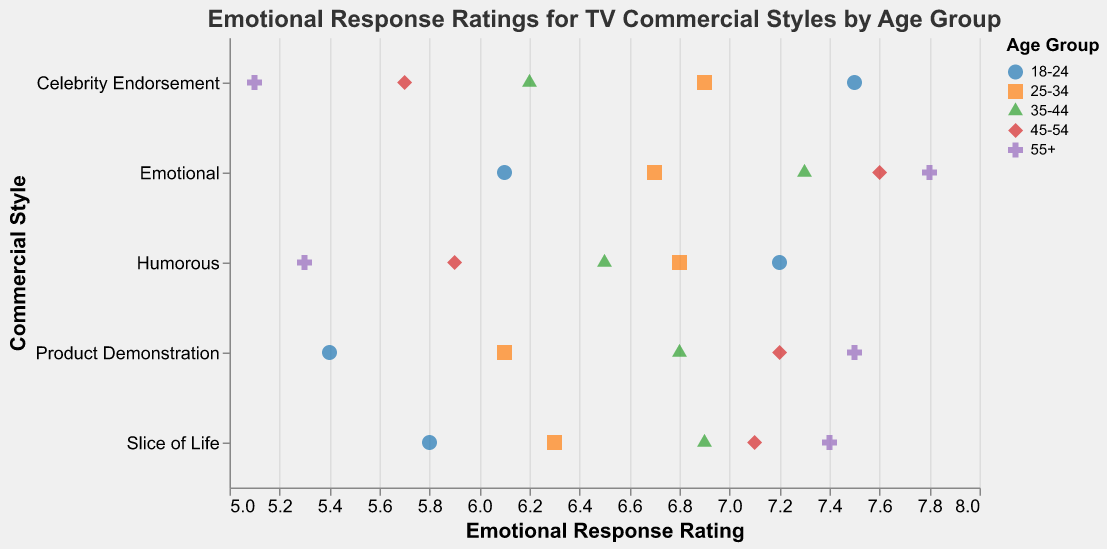What is the range of the "Emotional Response Rating" axis? The "Emotional Response Rating" axis ranges from 5 to 8, as shown by the scale domain on the x-axis.
Answer: 5 to 8 Which commercial style has the highest emotional response rating for the 55+ age group? The "Emotional" commercial style has the highest emotional response rating for the 55+ age group, with a score of 7.8.
Answer: Emotional How does the emotional response rating for "Humorous" commercials change as the age group increases? The emotional response rating for "Humorous" commercials decreases as the age group increases, starting from 7.2 for the 18-24 age group and dropping to 5.3 for the 55+ age group.
Answer: Decreases Which age group has the most varied emotional response ratings across different commercial styles? The age group 18-24 exhibits the most varied emotional response ratings, ranging from 5.4 for "Product Demonstration" to 7.5 for "Celebrity Endorsement".
Answer: 18-24 What is the average emotional response rating for the "Slice of Life" commercial style across all age groups? The emotional response ratings for "Slice of Life" commercial style across all age groups are 5.8, 6.3, 6.9, 7.1, and 7.4. Adding these together gives 33.5, and the average is 33.5 / 5 = 6.7.
Answer: 6.7 Which commercial style is rated highest by the 35-44 age group? The "Emotional" commercial style has the highest emotional response rating for the 35-44 age group, with a score of 7.3.
Answer: Emotional Compare the emotional response ratings of "Celebrity Endorsement" commercials for the 18-24 age group and the 55+ age group. "Celebrity Endorsement" commercials have an emotional response rating of 7.5 for the 18-24 age group and 5.1 for the 55+ age group. Thus, the rating is 2.4 points higher for the 18-24 age group.
Answer: 2.4 points higher for the 18-24 age group Which commercial style has the least variation in emotional response ratings across all age groups? The "Slice of Life" commercial style has ratings from 5.8 to 7.4, with differences being relatively small, showing the least variation compared to other styles.
Answer: Slice of Life What is the difference between the highest and lowest emotional response ratings for "Product Demonstration" commercials? The highest rating for "Product Demonstration" commercials is 7.5 (55+ age group) and the lowest is 5.4 (18-24 age group). The difference is 7.5 - 5.4 = 2.1.
Answer: 2.1 How does the average emotional response rating of "Emotional" commercials compare to that of "Humorous" commercials across all age groups? The average for "Emotional" commercials is (6.1 + 6.7 + 7.3 + 7.6 + 7.8) / 5 = 7.1. The average for "Humorous" commercials is (7.2 + 6.8 + 6.5 + 5.9 + 5.3) / 5 = 6.34. "Emotional" commercials have a higher average rating.
Answer: Emotional commercials have a higher average rating 